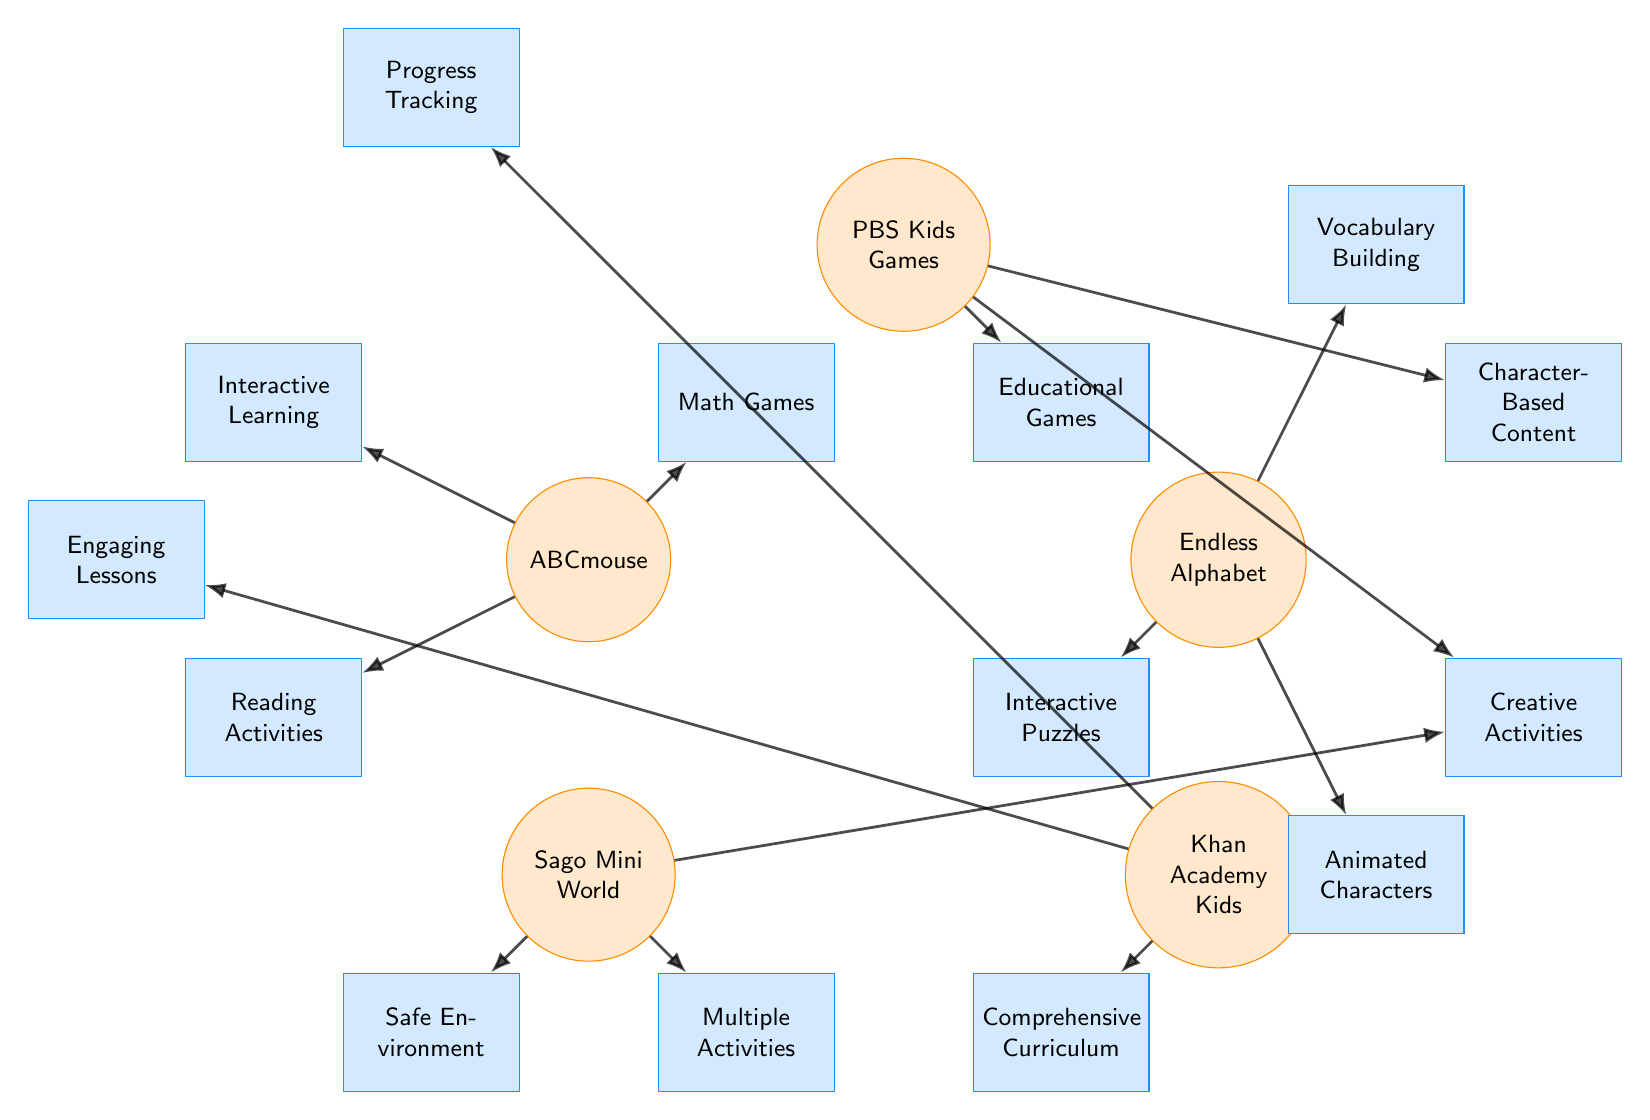What is the primary feature of ABCmouse? ABCmouse has three primary features, including Interactive Learning, Reading Activities, and Math Games. Since the question specifically asks for the primary feature, we can cite "Interactive Learning" as one of the main ones highlighted in the diagram.
Answer: Interactive Learning How many apps are connected to the feature 'Creative Activities'? In the diagram, 'Creative Activities' is connected to two apps: PBS Kids Games and Sago Mini World. By counting the edges that connect to the 'Creative Activities' feature, we arrive at this answer.
Answer: 2 Which app has the feature 'Progress Tracking'? Based on the diagram, 'Progress Tracking' is connected only to Khan Academy Kids. By identifying the connections of the features to the respective apps, Khan Academy Kids is the only app linked to this feature.
Answer: Khan Academy Kids Name a feature associated with Endless Alphabet. Looking at the connections in the diagram, Endless Alphabet is linked to three features: Vocabulary Building, Interactive Puzzles, and Animated Characters. Any of these would work, but answering with any one feature is acceptable.
Answer: Vocabulary Building What is the relationship between PBS Kids Games and Educational Games? PBS Kids Games is directly connected to the feature 'Educational Games' in the diagram. This reflects a direct relationship where the app provides this specific feature.
Answer: Direct connection Which app offers 'Comprehensive Curriculum'? The diagram indicates that only Khan Academy Kids has the 'Comprehensive Curriculum' feature associated with it. By identifying the features connected to the apps, we can ascertain that this feature is exclusive to Khan Academy Kids.
Answer: Khan Academy Kids List one feature of Sago Mini World. Sago Mini World is associated with three features: Creative Play, Safe Environment, and Multiple Activities. Any one of these features can be given as an answer.
Answer: Creative Play How many different features are connected to the app 'PBS Kids Games'? The app PBS Kids Games is connected to three features: Educational Games, Character-Based Content, and Creative Activities. By counting these connections, we can determine the answer.
Answer: 3 What type of content is 'Character-Based Content' linked to? The diagram shows that 'Character-Based Content' is connected to PBS Kids Games, indicating that this content type is specifically linked to this app.
Answer: PBS Kids Games 